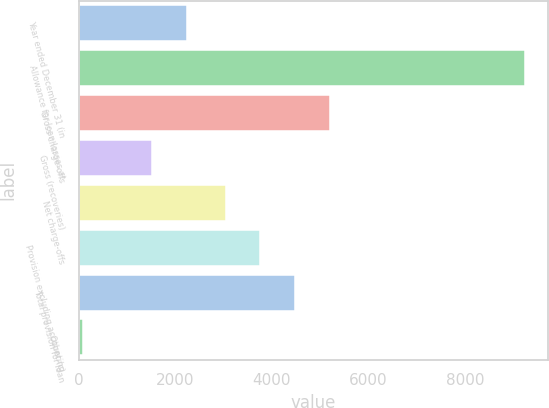Convert chart to OTSL. <chart><loc_0><loc_0><loc_500><loc_500><bar_chart><fcel>Year ended December 31 (in<fcel>Allowance for loan losses at<fcel>Gross charge-offs<fcel>Gross (recoveries)<fcel>Net charge-offs<fcel>Provision excluding accounting<fcel>Total provision for loan<fcel>Other (c)<nl><fcel>2238.3<fcel>9250.3<fcel>5202.3<fcel>1518.2<fcel>3042<fcel>3762.1<fcel>4482.2<fcel>78<nl></chart> 